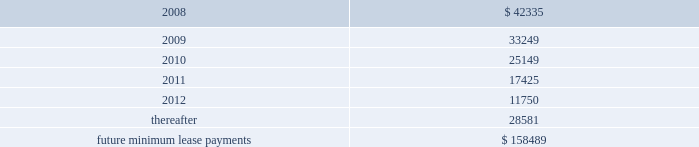Lkq corporation and subsidiaries notes to consolidated financial statements ( continued ) note 5 .
Long-term obligations ( continued ) as part of the consideration for business acquisitions completed during 2007 , 2006 and 2005 , we issued promissory notes totaling approximately $ 1.7 million , $ 7.2 million and $ 6.4 million , respectively .
The notes bear interest at annual rates of 3.0% ( 3.0 % ) to 6.0% ( 6.0 % ) , and interest is payable at maturity or in monthly installments .
We also assumed certain liabilities in connection with a business acquisition during the second quarter of 2005 , including a promissory note with a remaining principle balance of approximately $ 0.2 million .
The annual interest rate on the note , which was retired during 2006 , was note 6 .
Commitments and contingencies operating leases we are obligated under noncancelable operating leases for corporate office space , warehouse and distribution facilities , trucks and certain equipment .
The future minimum lease commitments under these leases at december 31 , 2007 are as follows ( in thousands ) : years ending december 31: .
Rental expense for operating leases was approximately $ 27.4 million , $ 18.6 million and $ 12.2 million during the years ended december 31 , 2007 , 2006 and 2005 , respectively .
We guaranty the residual values of the majority of our truck and equipment operating leases .
The residual values decline over the lease terms to a defined percentage of original cost .
In the event the lessor does not realize the residual value when a piece of equipment is sold , we would be responsible for a portion of the shortfall .
Similarly , if the lessor realizes more than the residual value when a piece of equipment is sold , we would be paid the amount realized over the residual value .
Had we terminated all of our operating leases subject to these guaranties at december 31 , 2007 , the guarantied residual value would have totaled approximately $ 24.0 million .
Litigation and related contingencies on december 2 , 2005 , ford global technologies , llc ( 2018 2018ford 2019 2019 ) filed a complaint with the united states international trade commission ( 2018 2018usitc 2019 2019 ) against keystone and five other named respondents , including four taiwan-based manufacturers .
On december 12 , 2005 , ford filed an amended complaint .
Both the complaint and the amended complaint contended that keystone and the other respondents infringed 14 design patents that ford alleges cover eight parts on the 2004-2005 .
What was the percentage change in rental expense from 2006 to 2007? 
Computations: ((27.4 - 18.6) / 18.6)
Answer: 0.47312. Lkq corporation and subsidiaries notes to consolidated financial statements ( continued ) note 5 .
Long-term obligations ( continued ) as part of the consideration for business acquisitions completed during 2007 , 2006 and 2005 , we issued promissory notes totaling approximately $ 1.7 million , $ 7.2 million and $ 6.4 million , respectively .
The notes bear interest at annual rates of 3.0% ( 3.0 % ) to 6.0% ( 6.0 % ) , and interest is payable at maturity or in monthly installments .
We also assumed certain liabilities in connection with a business acquisition during the second quarter of 2005 , including a promissory note with a remaining principle balance of approximately $ 0.2 million .
The annual interest rate on the note , which was retired during 2006 , was note 6 .
Commitments and contingencies operating leases we are obligated under noncancelable operating leases for corporate office space , warehouse and distribution facilities , trucks and certain equipment .
The future minimum lease commitments under these leases at december 31 , 2007 are as follows ( in thousands ) : years ending december 31: .
Rental expense for operating leases was approximately $ 27.4 million , $ 18.6 million and $ 12.2 million during the years ended december 31 , 2007 , 2006 and 2005 , respectively .
We guaranty the residual values of the majority of our truck and equipment operating leases .
The residual values decline over the lease terms to a defined percentage of original cost .
In the event the lessor does not realize the residual value when a piece of equipment is sold , we would be responsible for a portion of the shortfall .
Similarly , if the lessor realizes more than the residual value when a piece of equipment is sold , we would be paid the amount realized over the residual value .
Had we terminated all of our operating leases subject to these guaranties at december 31 , 2007 , the guarantied residual value would have totaled approximately $ 24.0 million .
Litigation and related contingencies on december 2 , 2005 , ford global technologies , llc ( 2018 2018ford 2019 2019 ) filed a complaint with the united states international trade commission ( 2018 2018usitc 2019 2019 ) against keystone and five other named respondents , including four taiwan-based manufacturers .
On december 12 , 2005 , ford filed an amended complaint .
Both the complaint and the amended complaint contended that keystone and the other respondents infringed 14 design patents that ford alleges cover eight parts on the 2004-2005 .
What was the average rental expense from 2005 to 2007 in millions? 
Computations: ((((27.4 + 18.6) + 12.2) + 3) / 2)
Answer: 30.6. Lkq corporation and subsidiaries notes to consolidated financial statements ( continued ) note 5 .
Long-term obligations ( continued ) as part of the consideration for business acquisitions completed during 2007 , 2006 and 2005 , we issued promissory notes totaling approximately $ 1.7 million , $ 7.2 million and $ 6.4 million , respectively .
The notes bear interest at annual rates of 3.0% ( 3.0 % ) to 6.0% ( 6.0 % ) , and interest is payable at maturity or in monthly installments .
We also assumed certain liabilities in connection with a business acquisition during the second quarter of 2005 , including a promissory note with a remaining principle balance of approximately $ 0.2 million .
The annual interest rate on the note , which was retired during 2006 , was note 6 .
Commitments and contingencies operating leases we are obligated under noncancelable operating leases for corporate office space , warehouse and distribution facilities , trucks and certain equipment .
The future minimum lease commitments under these leases at december 31 , 2007 are as follows ( in thousands ) : years ending december 31: .
Rental expense for operating leases was approximately $ 27.4 million , $ 18.6 million and $ 12.2 million during the years ended december 31 , 2007 , 2006 and 2005 , respectively .
We guaranty the residual values of the majority of our truck and equipment operating leases .
The residual values decline over the lease terms to a defined percentage of original cost .
In the event the lessor does not realize the residual value when a piece of equipment is sold , we would be responsible for a portion of the shortfall .
Similarly , if the lessor realizes more than the residual value when a piece of equipment is sold , we would be paid the amount realized over the residual value .
Had we terminated all of our operating leases subject to these guaranties at december 31 , 2007 , the guarantied residual value would have totaled approximately $ 24.0 million .
Litigation and related contingencies on december 2 , 2005 , ford global technologies , llc ( 2018 2018ford 2019 2019 ) filed a complaint with the united states international trade commission ( 2018 2018usitc 2019 2019 ) against keystone and five other named respondents , including four taiwan-based manufacturers .
On december 12 , 2005 , ford filed an amended complaint .
Both the complaint and the amended complaint contended that keystone and the other respondents infringed 14 design patents that ford alleges cover eight parts on the 2004-2005 .
In 2007 what was the percent of the the total future minimum lease commitments and contingencies for operating leases that was due in 2009? 
Computations: (33249 / 158489)
Answer: 0.20979. 